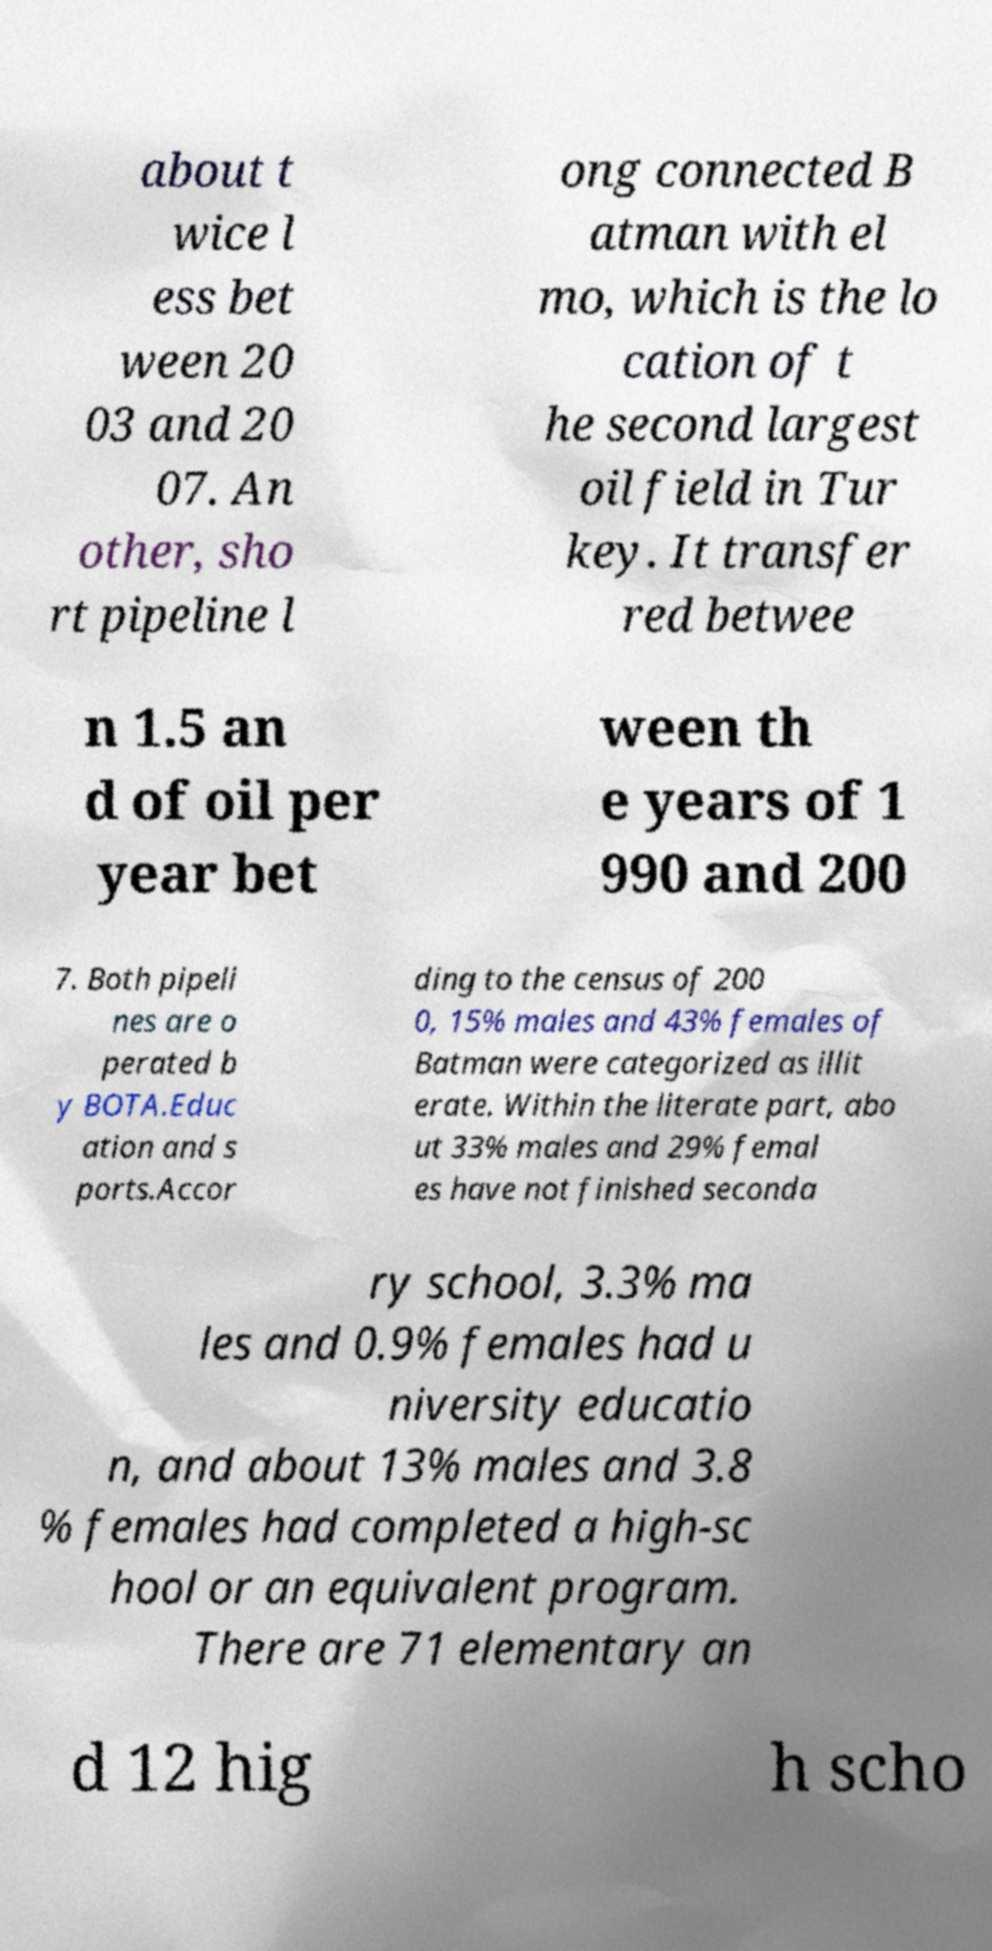There's text embedded in this image that I need extracted. Can you transcribe it verbatim? about t wice l ess bet ween 20 03 and 20 07. An other, sho rt pipeline l ong connected B atman with el mo, which is the lo cation of t he second largest oil field in Tur key. It transfer red betwee n 1.5 an d of oil per year bet ween th e years of 1 990 and 200 7. Both pipeli nes are o perated b y BOTA.Educ ation and s ports.Accor ding to the census of 200 0, 15% males and 43% females of Batman were categorized as illit erate. Within the literate part, abo ut 33% males and 29% femal es have not finished seconda ry school, 3.3% ma les and 0.9% females had u niversity educatio n, and about 13% males and 3.8 % females had completed a high-sc hool or an equivalent program. There are 71 elementary an d 12 hig h scho 